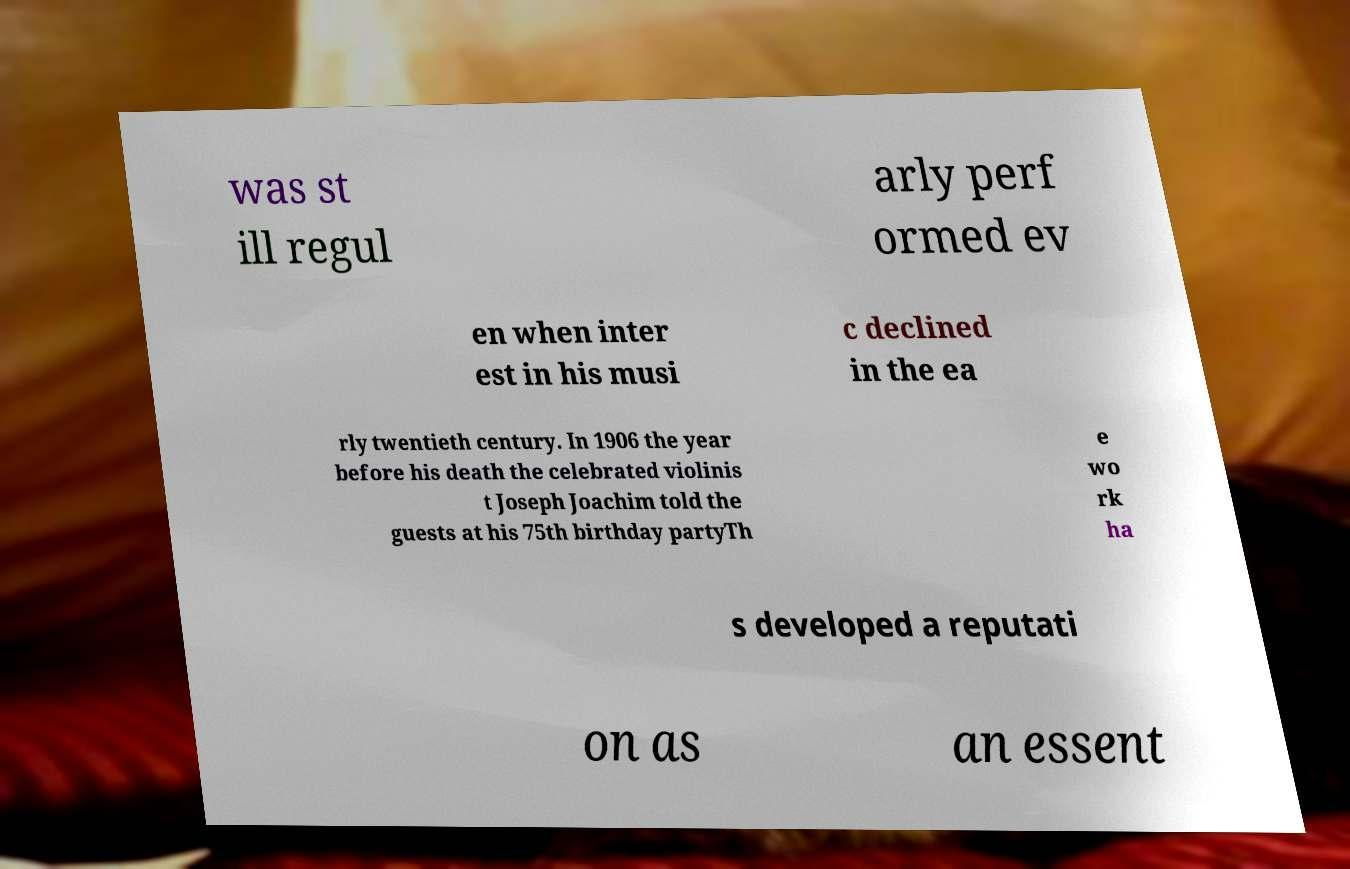Please read and relay the text visible in this image. What does it say? was st ill regul arly perf ormed ev en when inter est in his musi c declined in the ea rly twentieth century. In 1906 the year before his death the celebrated violinis t Joseph Joachim told the guests at his 75th birthday partyTh e wo rk ha s developed a reputati on as an essent 